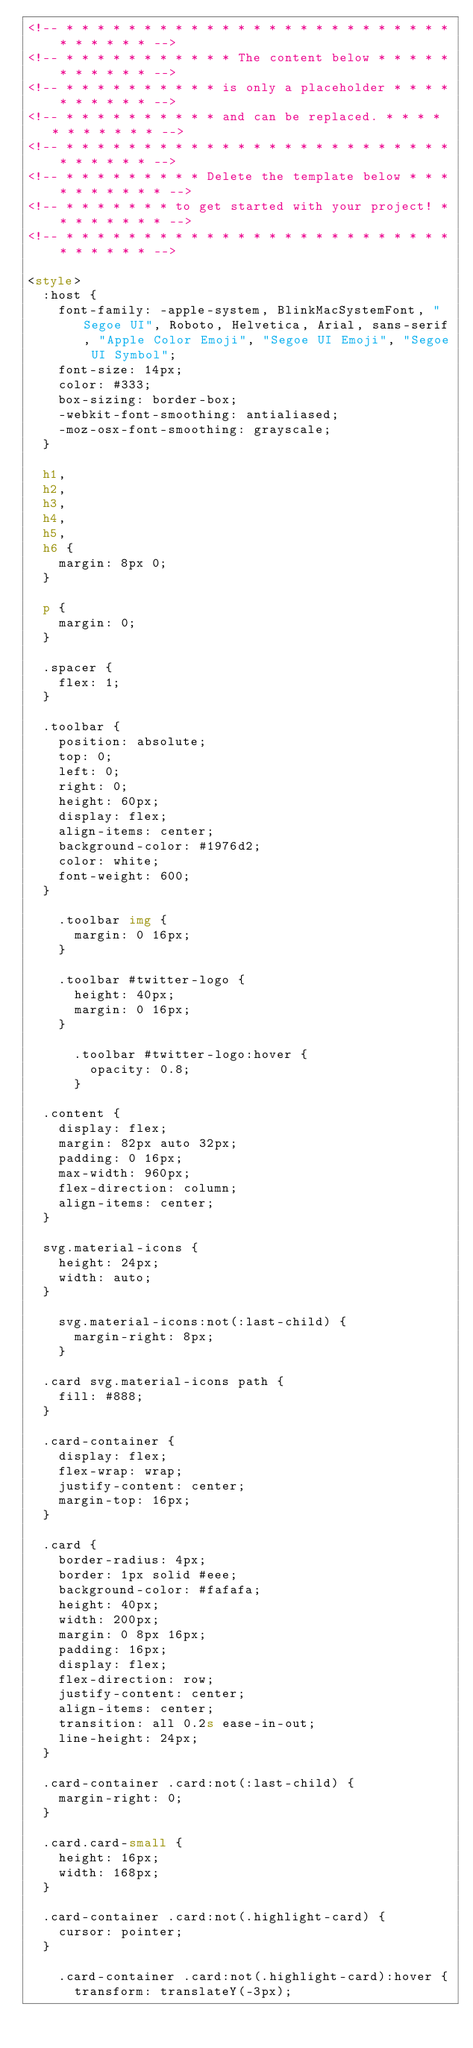Convert code to text. <code><loc_0><loc_0><loc_500><loc_500><_HTML_><!-- * * * * * * * * * * * * * * * * * * * * * * * * * * * * * * * -->
<!-- * * * * * * * * * * * The content below * * * * * * * * * * * -->
<!-- * * * * * * * * * * is only a placeholder * * * * * * * * * * -->
<!-- * * * * * * * * * * and can be replaced. * * * * * * * * * * * -->
<!-- * * * * * * * * * * * * * * * * * * * * * * * * * * * * * * * -->
<!-- * * * * * * * * * Delete the template below * * * * * * * * * * -->
<!-- * * * * * * * to get started with your project! * * * * * * * * -->
<!-- * * * * * * * * * * * * * * * * * * * * * * * * * * * * * * * -->

<style>
  :host {
    font-family: -apple-system, BlinkMacSystemFont, "Segoe UI", Roboto, Helvetica, Arial, sans-serif, "Apple Color Emoji", "Segoe UI Emoji", "Segoe UI Symbol";
    font-size: 14px;
    color: #333;
    box-sizing: border-box;
    -webkit-font-smoothing: antialiased;
    -moz-osx-font-smoothing: grayscale;
  }

  h1,
  h2,
  h3,
  h4,
  h5,
  h6 {
    margin: 8px 0;
  }

  p {
    margin: 0;
  }

  .spacer {
    flex: 1;
  }

  .toolbar {
    position: absolute;
    top: 0;
    left: 0;
    right: 0;
    height: 60px;
    display: flex;
    align-items: center;
    background-color: #1976d2;
    color: white;
    font-weight: 600;
  }

    .toolbar img {
      margin: 0 16px;
    }

    .toolbar #twitter-logo {
      height: 40px;
      margin: 0 16px;
    }

      .toolbar #twitter-logo:hover {
        opacity: 0.8;
      }

  .content {
    display: flex;
    margin: 82px auto 32px;
    padding: 0 16px;
    max-width: 960px;
    flex-direction: column;
    align-items: center;
  }

  svg.material-icons {
    height: 24px;
    width: auto;
  }

    svg.material-icons:not(:last-child) {
      margin-right: 8px;
    }

  .card svg.material-icons path {
    fill: #888;
  }

  .card-container {
    display: flex;
    flex-wrap: wrap;
    justify-content: center;
    margin-top: 16px;
  }

  .card {
    border-radius: 4px;
    border: 1px solid #eee;
    background-color: #fafafa;
    height: 40px;
    width: 200px;
    margin: 0 8px 16px;
    padding: 16px;
    display: flex;
    flex-direction: row;
    justify-content: center;
    align-items: center;
    transition: all 0.2s ease-in-out;
    line-height: 24px;
  }

  .card-container .card:not(:last-child) {
    margin-right: 0;
  }

  .card.card-small {
    height: 16px;
    width: 168px;
  }

  .card-container .card:not(.highlight-card) {
    cursor: pointer;
  }

    .card-container .card:not(.highlight-card):hover {
      transform: translateY(-3px);</code> 